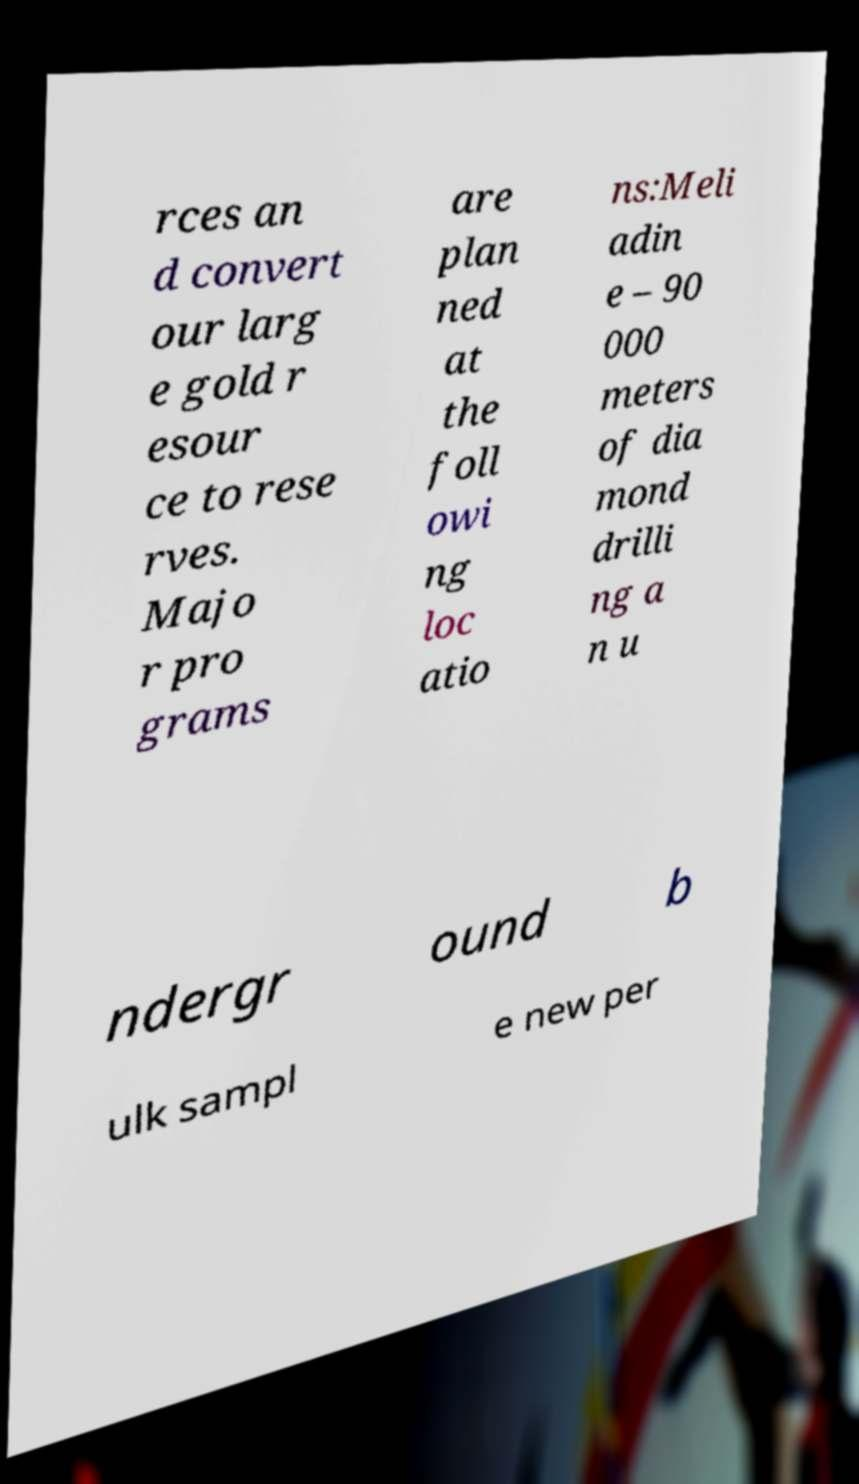Can you read and provide the text displayed in the image?This photo seems to have some interesting text. Can you extract and type it out for me? rces an d convert our larg e gold r esour ce to rese rves. Majo r pro grams are plan ned at the foll owi ng loc atio ns:Meli adin e – 90 000 meters of dia mond drilli ng a n u ndergr ound b ulk sampl e new per 